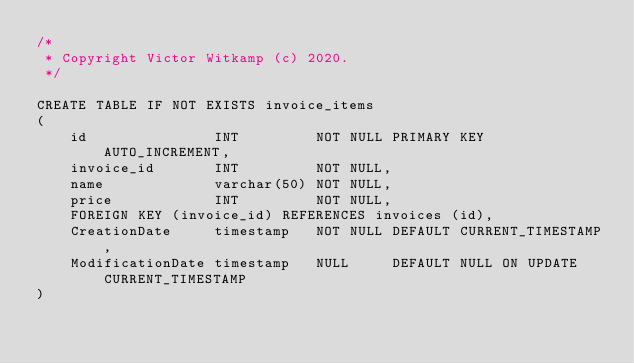<code> <loc_0><loc_0><loc_500><loc_500><_SQL_>/*
 * Copyright Victor Witkamp (c) 2020.
 */

CREATE TABLE IF NOT EXISTS invoice_items
(
    id               INT         NOT NULL PRIMARY KEY AUTO_INCREMENT,
    invoice_id       INT         NOT NULL,
    name             varchar(50) NOT NULL,
    price            INT         NOT NULL,
    FOREIGN KEY (invoice_id) REFERENCES invoices (id),
    CreationDate     timestamp   NOT NULL DEFAULT CURRENT_TIMESTAMP,
    ModificationDate timestamp   NULL     DEFAULT NULL ON UPDATE CURRENT_TIMESTAMP
)</code> 